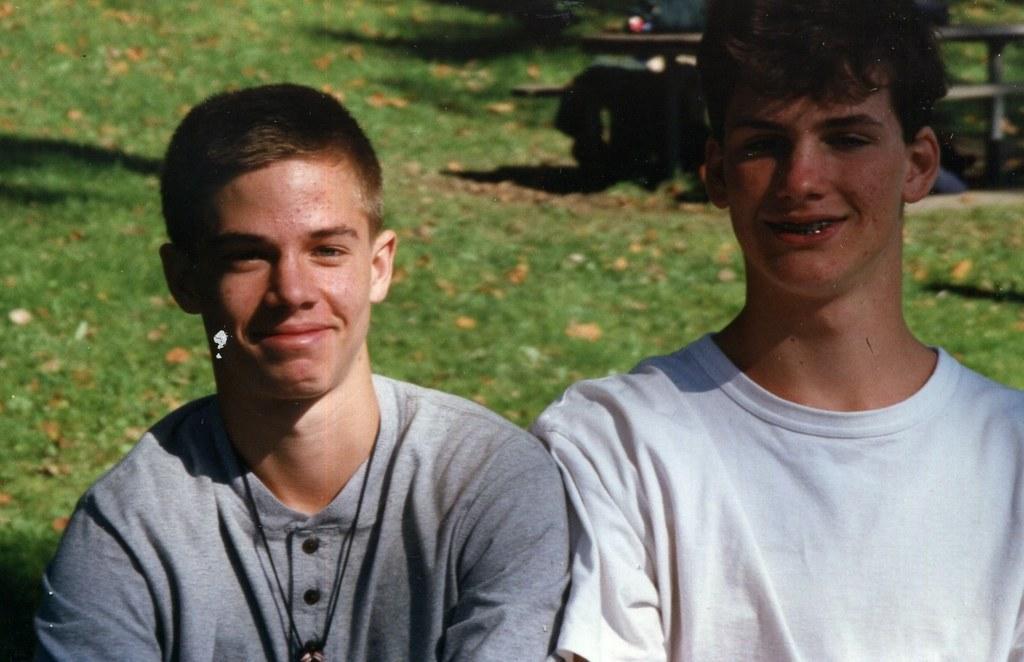Describe this image in one or two sentences. On the left side, there is a person in a t-shirt, smiling. On the right side, there is a person in a white color t-shirt, smiling. In the background, there is an object, on which there is grass. 